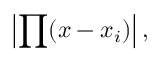<formula> <loc_0><loc_0><loc_500><loc_500>\left | \prod ( x - x _ { i } ) \right | ,</formula> 